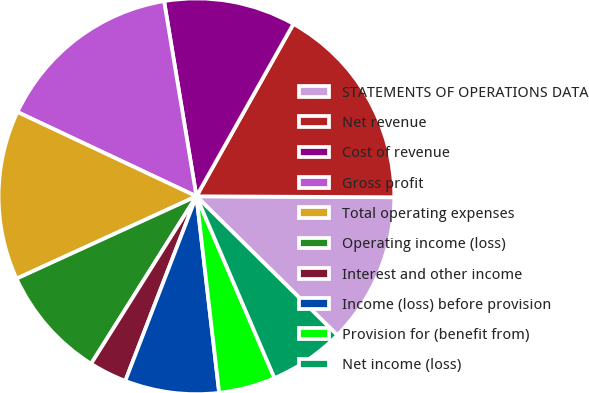Convert chart. <chart><loc_0><loc_0><loc_500><loc_500><pie_chart><fcel>STATEMENTS OF OPERATIONS DATA<fcel>Net revenue<fcel>Cost of revenue<fcel>Gross profit<fcel>Total operating expenses<fcel>Operating income (loss)<fcel>Interest and other income<fcel>Income (loss) before provision<fcel>Provision for (benefit from)<fcel>Net income (loss)<nl><fcel>12.31%<fcel>16.92%<fcel>10.77%<fcel>15.38%<fcel>13.84%<fcel>9.23%<fcel>3.08%<fcel>7.69%<fcel>4.62%<fcel>6.16%<nl></chart> 